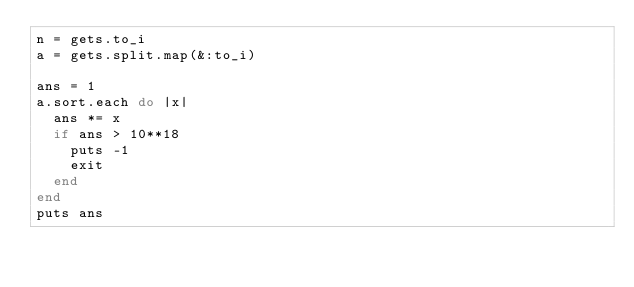Convert code to text. <code><loc_0><loc_0><loc_500><loc_500><_Ruby_>n = gets.to_i
a = gets.split.map(&:to_i)

ans = 1
a.sort.each do |x|
  ans *= x
  if ans > 10**18
    puts -1
    exit
  end
end
puts ans</code> 